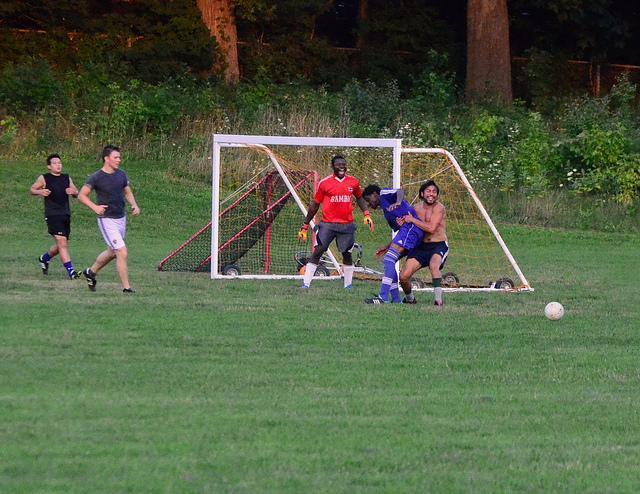How many people are there?
Give a very brief answer. 5. How many horses are in the picture?
Give a very brief answer. 0. 